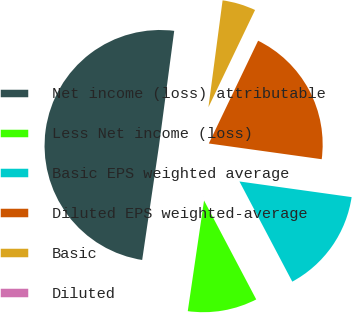<chart> <loc_0><loc_0><loc_500><loc_500><pie_chart><fcel>Net income (loss) attributable<fcel>Less Net income (loss)<fcel>Basic EPS weighted average<fcel>Diluted EPS weighted-average<fcel>Basic<fcel>Diluted<nl><fcel>49.77%<fcel>10.05%<fcel>15.07%<fcel>20.09%<fcel>5.02%<fcel>0.0%<nl></chart> 